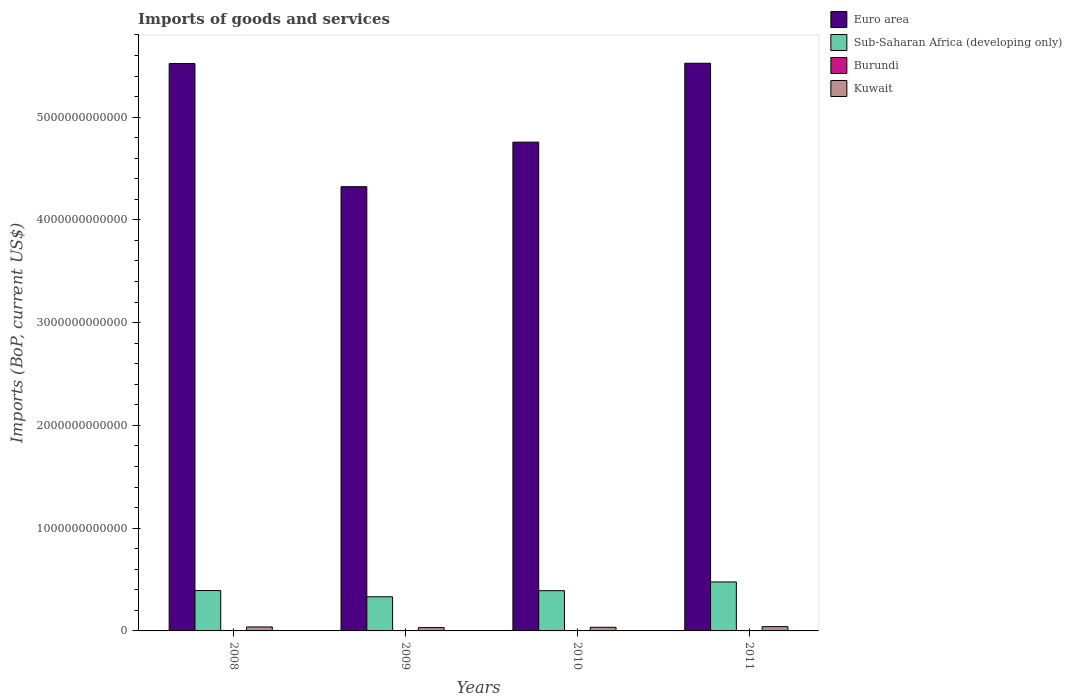How many different coloured bars are there?
Your answer should be compact. 4. How many bars are there on the 1st tick from the right?
Give a very brief answer. 4. What is the amount spent on imports in Kuwait in 2009?
Your answer should be compact. 3.23e+1. Across all years, what is the maximum amount spent on imports in Sub-Saharan Africa (developing only)?
Your answer should be very brief. 4.76e+11. Across all years, what is the minimum amount spent on imports in Euro area?
Offer a very short reply. 4.32e+12. What is the total amount spent on imports in Burundi in the graph?
Offer a terse response. 2.49e+09. What is the difference between the amount spent on imports in Kuwait in 2008 and that in 2010?
Provide a succinct answer. 3.36e+09. What is the difference between the amount spent on imports in Euro area in 2011 and the amount spent on imports in Kuwait in 2009?
Give a very brief answer. 5.49e+12. What is the average amount spent on imports in Burundi per year?
Keep it short and to the point. 6.21e+08. In the year 2010, what is the difference between the amount spent on imports in Burundi and amount spent on imports in Sub-Saharan Africa (developing only)?
Your response must be concise. -3.91e+11. In how many years, is the amount spent on imports in Kuwait greater than 4400000000000 US$?
Offer a terse response. 0. What is the ratio of the amount spent on imports in Kuwait in 2010 to that in 2011?
Provide a succinct answer. 0.85. Is the amount spent on imports in Burundi in 2009 less than that in 2010?
Keep it short and to the point. Yes. What is the difference between the highest and the second highest amount spent on imports in Euro area?
Provide a short and direct response. 3.06e+09. What is the difference between the highest and the lowest amount spent on imports in Kuwait?
Provide a short and direct response. 9.34e+09. Is the sum of the amount spent on imports in Sub-Saharan Africa (developing only) in 2010 and 2011 greater than the maximum amount spent on imports in Burundi across all years?
Offer a terse response. Yes. What does the 2nd bar from the right in 2009 represents?
Give a very brief answer. Burundi. What is the difference between two consecutive major ticks on the Y-axis?
Your response must be concise. 1.00e+12. How many legend labels are there?
Offer a terse response. 4. What is the title of the graph?
Provide a short and direct response. Imports of goods and services. What is the label or title of the Y-axis?
Make the answer very short. Imports (BoP, current US$). What is the Imports (BoP, current US$) of Euro area in 2008?
Keep it short and to the point. 5.52e+12. What is the Imports (BoP, current US$) in Sub-Saharan Africa (developing only) in 2008?
Give a very brief answer. 3.93e+11. What is the Imports (BoP, current US$) in Burundi in 2008?
Your answer should be compact. 5.94e+08. What is the Imports (BoP, current US$) in Kuwait in 2008?
Offer a very short reply. 3.87e+1. What is the Imports (BoP, current US$) in Euro area in 2009?
Make the answer very short. 4.32e+12. What is the Imports (BoP, current US$) in Sub-Saharan Africa (developing only) in 2009?
Give a very brief answer. 3.32e+11. What is the Imports (BoP, current US$) of Burundi in 2009?
Provide a short and direct response. 5.20e+08. What is the Imports (BoP, current US$) in Kuwait in 2009?
Give a very brief answer. 3.23e+1. What is the Imports (BoP, current US$) of Euro area in 2010?
Your answer should be very brief. 4.76e+12. What is the Imports (BoP, current US$) of Sub-Saharan Africa (developing only) in 2010?
Ensure brevity in your answer.  3.92e+11. What is the Imports (BoP, current US$) in Burundi in 2010?
Ensure brevity in your answer.  6.07e+08. What is the Imports (BoP, current US$) of Kuwait in 2010?
Provide a succinct answer. 3.54e+1. What is the Imports (BoP, current US$) in Euro area in 2011?
Your answer should be compact. 5.52e+12. What is the Imports (BoP, current US$) in Sub-Saharan Africa (developing only) in 2011?
Make the answer very short. 4.76e+11. What is the Imports (BoP, current US$) in Burundi in 2011?
Offer a terse response. 7.65e+08. What is the Imports (BoP, current US$) of Kuwait in 2011?
Provide a succinct answer. 4.16e+1. Across all years, what is the maximum Imports (BoP, current US$) of Euro area?
Keep it short and to the point. 5.52e+12. Across all years, what is the maximum Imports (BoP, current US$) in Sub-Saharan Africa (developing only)?
Give a very brief answer. 4.76e+11. Across all years, what is the maximum Imports (BoP, current US$) of Burundi?
Your response must be concise. 7.65e+08. Across all years, what is the maximum Imports (BoP, current US$) in Kuwait?
Offer a very short reply. 4.16e+1. Across all years, what is the minimum Imports (BoP, current US$) in Euro area?
Your response must be concise. 4.32e+12. Across all years, what is the minimum Imports (BoP, current US$) in Sub-Saharan Africa (developing only)?
Provide a succinct answer. 3.32e+11. Across all years, what is the minimum Imports (BoP, current US$) of Burundi?
Provide a succinct answer. 5.20e+08. Across all years, what is the minimum Imports (BoP, current US$) in Kuwait?
Your answer should be very brief. 3.23e+1. What is the total Imports (BoP, current US$) of Euro area in the graph?
Your response must be concise. 2.01e+13. What is the total Imports (BoP, current US$) in Sub-Saharan Africa (developing only) in the graph?
Make the answer very short. 1.59e+12. What is the total Imports (BoP, current US$) in Burundi in the graph?
Provide a short and direct response. 2.49e+09. What is the total Imports (BoP, current US$) of Kuwait in the graph?
Your answer should be very brief. 1.48e+11. What is the difference between the Imports (BoP, current US$) of Euro area in 2008 and that in 2009?
Make the answer very short. 1.20e+12. What is the difference between the Imports (BoP, current US$) in Sub-Saharan Africa (developing only) in 2008 and that in 2009?
Offer a very short reply. 6.07e+1. What is the difference between the Imports (BoP, current US$) of Burundi in 2008 and that in 2009?
Provide a short and direct response. 7.46e+07. What is the difference between the Imports (BoP, current US$) in Kuwait in 2008 and that in 2009?
Provide a short and direct response. 6.45e+09. What is the difference between the Imports (BoP, current US$) of Euro area in 2008 and that in 2010?
Offer a very short reply. 7.65e+11. What is the difference between the Imports (BoP, current US$) of Sub-Saharan Africa (developing only) in 2008 and that in 2010?
Give a very brief answer. 1.30e+09. What is the difference between the Imports (BoP, current US$) of Burundi in 2008 and that in 2010?
Give a very brief answer. -1.25e+07. What is the difference between the Imports (BoP, current US$) in Kuwait in 2008 and that in 2010?
Your response must be concise. 3.36e+09. What is the difference between the Imports (BoP, current US$) in Euro area in 2008 and that in 2011?
Ensure brevity in your answer.  -3.06e+09. What is the difference between the Imports (BoP, current US$) in Sub-Saharan Africa (developing only) in 2008 and that in 2011?
Offer a terse response. -8.35e+1. What is the difference between the Imports (BoP, current US$) in Burundi in 2008 and that in 2011?
Provide a short and direct response. -1.71e+08. What is the difference between the Imports (BoP, current US$) of Kuwait in 2008 and that in 2011?
Provide a short and direct response. -2.89e+09. What is the difference between the Imports (BoP, current US$) in Euro area in 2009 and that in 2010?
Offer a very short reply. -4.34e+11. What is the difference between the Imports (BoP, current US$) of Sub-Saharan Africa (developing only) in 2009 and that in 2010?
Your response must be concise. -5.94e+1. What is the difference between the Imports (BoP, current US$) of Burundi in 2009 and that in 2010?
Provide a short and direct response. -8.71e+07. What is the difference between the Imports (BoP, current US$) of Kuwait in 2009 and that in 2010?
Provide a short and direct response. -3.08e+09. What is the difference between the Imports (BoP, current US$) of Euro area in 2009 and that in 2011?
Your response must be concise. -1.20e+12. What is the difference between the Imports (BoP, current US$) in Sub-Saharan Africa (developing only) in 2009 and that in 2011?
Ensure brevity in your answer.  -1.44e+11. What is the difference between the Imports (BoP, current US$) of Burundi in 2009 and that in 2011?
Give a very brief answer. -2.46e+08. What is the difference between the Imports (BoP, current US$) of Kuwait in 2009 and that in 2011?
Keep it short and to the point. -9.34e+09. What is the difference between the Imports (BoP, current US$) in Euro area in 2010 and that in 2011?
Give a very brief answer. -7.68e+11. What is the difference between the Imports (BoP, current US$) in Sub-Saharan Africa (developing only) in 2010 and that in 2011?
Ensure brevity in your answer.  -8.48e+1. What is the difference between the Imports (BoP, current US$) of Burundi in 2010 and that in 2011?
Provide a short and direct response. -1.59e+08. What is the difference between the Imports (BoP, current US$) in Kuwait in 2010 and that in 2011?
Offer a very short reply. -6.26e+09. What is the difference between the Imports (BoP, current US$) in Euro area in 2008 and the Imports (BoP, current US$) in Sub-Saharan Africa (developing only) in 2009?
Keep it short and to the point. 5.19e+12. What is the difference between the Imports (BoP, current US$) in Euro area in 2008 and the Imports (BoP, current US$) in Burundi in 2009?
Give a very brief answer. 5.52e+12. What is the difference between the Imports (BoP, current US$) in Euro area in 2008 and the Imports (BoP, current US$) in Kuwait in 2009?
Your answer should be compact. 5.49e+12. What is the difference between the Imports (BoP, current US$) of Sub-Saharan Africa (developing only) in 2008 and the Imports (BoP, current US$) of Burundi in 2009?
Give a very brief answer. 3.92e+11. What is the difference between the Imports (BoP, current US$) in Sub-Saharan Africa (developing only) in 2008 and the Imports (BoP, current US$) in Kuwait in 2009?
Keep it short and to the point. 3.61e+11. What is the difference between the Imports (BoP, current US$) of Burundi in 2008 and the Imports (BoP, current US$) of Kuwait in 2009?
Your answer should be very brief. -3.17e+1. What is the difference between the Imports (BoP, current US$) of Euro area in 2008 and the Imports (BoP, current US$) of Sub-Saharan Africa (developing only) in 2010?
Make the answer very short. 5.13e+12. What is the difference between the Imports (BoP, current US$) in Euro area in 2008 and the Imports (BoP, current US$) in Burundi in 2010?
Provide a succinct answer. 5.52e+12. What is the difference between the Imports (BoP, current US$) in Euro area in 2008 and the Imports (BoP, current US$) in Kuwait in 2010?
Ensure brevity in your answer.  5.49e+12. What is the difference between the Imports (BoP, current US$) of Sub-Saharan Africa (developing only) in 2008 and the Imports (BoP, current US$) of Burundi in 2010?
Provide a short and direct response. 3.92e+11. What is the difference between the Imports (BoP, current US$) of Sub-Saharan Africa (developing only) in 2008 and the Imports (BoP, current US$) of Kuwait in 2010?
Keep it short and to the point. 3.58e+11. What is the difference between the Imports (BoP, current US$) of Burundi in 2008 and the Imports (BoP, current US$) of Kuwait in 2010?
Provide a short and direct response. -3.48e+1. What is the difference between the Imports (BoP, current US$) in Euro area in 2008 and the Imports (BoP, current US$) in Sub-Saharan Africa (developing only) in 2011?
Your answer should be very brief. 5.04e+12. What is the difference between the Imports (BoP, current US$) of Euro area in 2008 and the Imports (BoP, current US$) of Burundi in 2011?
Your answer should be very brief. 5.52e+12. What is the difference between the Imports (BoP, current US$) of Euro area in 2008 and the Imports (BoP, current US$) of Kuwait in 2011?
Make the answer very short. 5.48e+12. What is the difference between the Imports (BoP, current US$) in Sub-Saharan Africa (developing only) in 2008 and the Imports (BoP, current US$) in Burundi in 2011?
Your answer should be very brief. 3.92e+11. What is the difference between the Imports (BoP, current US$) in Sub-Saharan Africa (developing only) in 2008 and the Imports (BoP, current US$) in Kuwait in 2011?
Your answer should be compact. 3.51e+11. What is the difference between the Imports (BoP, current US$) in Burundi in 2008 and the Imports (BoP, current US$) in Kuwait in 2011?
Offer a very short reply. -4.10e+1. What is the difference between the Imports (BoP, current US$) of Euro area in 2009 and the Imports (BoP, current US$) of Sub-Saharan Africa (developing only) in 2010?
Offer a terse response. 3.93e+12. What is the difference between the Imports (BoP, current US$) of Euro area in 2009 and the Imports (BoP, current US$) of Burundi in 2010?
Provide a succinct answer. 4.32e+12. What is the difference between the Imports (BoP, current US$) in Euro area in 2009 and the Imports (BoP, current US$) in Kuwait in 2010?
Your response must be concise. 4.29e+12. What is the difference between the Imports (BoP, current US$) in Sub-Saharan Africa (developing only) in 2009 and the Imports (BoP, current US$) in Burundi in 2010?
Provide a short and direct response. 3.32e+11. What is the difference between the Imports (BoP, current US$) of Sub-Saharan Africa (developing only) in 2009 and the Imports (BoP, current US$) of Kuwait in 2010?
Your response must be concise. 2.97e+11. What is the difference between the Imports (BoP, current US$) of Burundi in 2009 and the Imports (BoP, current US$) of Kuwait in 2010?
Provide a succinct answer. -3.48e+1. What is the difference between the Imports (BoP, current US$) of Euro area in 2009 and the Imports (BoP, current US$) of Sub-Saharan Africa (developing only) in 2011?
Provide a succinct answer. 3.85e+12. What is the difference between the Imports (BoP, current US$) of Euro area in 2009 and the Imports (BoP, current US$) of Burundi in 2011?
Keep it short and to the point. 4.32e+12. What is the difference between the Imports (BoP, current US$) of Euro area in 2009 and the Imports (BoP, current US$) of Kuwait in 2011?
Ensure brevity in your answer.  4.28e+12. What is the difference between the Imports (BoP, current US$) of Sub-Saharan Africa (developing only) in 2009 and the Imports (BoP, current US$) of Burundi in 2011?
Provide a short and direct response. 3.31e+11. What is the difference between the Imports (BoP, current US$) of Sub-Saharan Africa (developing only) in 2009 and the Imports (BoP, current US$) of Kuwait in 2011?
Make the answer very short. 2.91e+11. What is the difference between the Imports (BoP, current US$) in Burundi in 2009 and the Imports (BoP, current US$) in Kuwait in 2011?
Ensure brevity in your answer.  -4.11e+1. What is the difference between the Imports (BoP, current US$) in Euro area in 2010 and the Imports (BoP, current US$) in Sub-Saharan Africa (developing only) in 2011?
Your response must be concise. 4.28e+12. What is the difference between the Imports (BoP, current US$) of Euro area in 2010 and the Imports (BoP, current US$) of Burundi in 2011?
Make the answer very short. 4.76e+12. What is the difference between the Imports (BoP, current US$) of Euro area in 2010 and the Imports (BoP, current US$) of Kuwait in 2011?
Your answer should be very brief. 4.71e+12. What is the difference between the Imports (BoP, current US$) of Sub-Saharan Africa (developing only) in 2010 and the Imports (BoP, current US$) of Burundi in 2011?
Your response must be concise. 3.91e+11. What is the difference between the Imports (BoP, current US$) of Sub-Saharan Africa (developing only) in 2010 and the Imports (BoP, current US$) of Kuwait in 2011?
Your answer should be compact. 3.50e+11. What is the difference between the Imports (BoP, current US$) in Burundi in 2010 and the Imports (BoP, current US$) in Kuwait in 2011?
Keep it short and to the point. -4.10e+1. What is the average Imports (BoP, current US$) of Euro area per year?
Make the answer very short. 5.03e+12. What is the average Imports (BoP, current US$) in Sub-Saharan Africa (developing only) per year?
Your answer should be compact. 3.98e+11. What is the average Imports (BoP, current US$) in Burundi per year?
Offer a very short reply. 6.21e+08. What is the average Imports (BoP, current US$) of Kuwait per year?
Provide a succinct answer. 3.70e+1. In the year 2008, what is the difference between the Imports (BoP, current US$) in Euro area and Imports (BoP, current US$) in Sub-Saharan Africa (developing only)?
Your answer should be compact. 5.13e+12. In the year 2008, what is the difference between the Imports (BoP, current US$) of Euro area and Imports (BoP, current US$) of Burundi?
Keep it short and to the point. 5.52e+12. In the year 2008, what is the difference between the Imports (BoP, current US$) in Euro area and Imports (BoP, current US$) in Kuwait?
Keep it short and to the point. 5.48e+12. In the year 2008, what is the difference between the Imports (BoP, current US$) in Sub-Saharan Africa (developing only) and Imports (BoP, current US$) in Burundi?
Keep it short and to the point. 3.92e+11. In the year 2008, what is the difference between the Imports (BoP, current US$) of Sub-Saharan Africa (developing only) and Imports (BoP, current US$) of Kuwait?
Ensure brevity in your answer.  3.54e+11. In the year 2008, what is the difference between the Imports (BoP, current US$) in Burundi and Imports (BoP, current US$) in Kuwait?
Keep it short and to the point. -3.81e+1. In the year 2009, what is the difference between the Imports (BoP, current US$) of Euro area and Imports (BoP, current US$) of Sub-Saharan Africa (developing only)?
Make the answer very short. 3.99e+12. In the year 2009, what is the difference between the Imports (BoP, current US$) of Euro area and Imports (BoP, current US$) of Burundi?
Your answer should be very brief. 4.32e+12. In the year 2009, what is the difference between the Imports (BoP, current US$) of Euro area and Imports (BoP, current US$) of Kuwait?
Give a very brief answer. 4.29e+12. In the year 2009, what is the difference between the Imports (BoP, current US$) of Sub-Saharan Africa (developing only) and Imports (BoP, current US$) of Burundi?
Your response must be concise. 3.32e+11. In the year 2009, what is the difference between the Imports (BoP, current US$) of Sub-Saharan Africa (developing only) and Imports (BoP, current US$) of Kuwait?
Provide a succinct answer. 3.00e+11. In the year 2009, what is the difference between the Imports (BoP, current US$) in Burundi and Imports (BoP, current US$) in Kuwait?
Ensure brevity in your answer.  -3.18e+1. In the year 2010, what is the difference between the Imports (BoP, current US$) in Euro area and Imports (BoP, current US$) in Sub-Saharan Africa (developing only)?
Ensure brevity in your answer.  4.36e+12. In the year 2010, what is the difference between the Imports (BoP, current US$) in Euro area and Imports (BoP, current US$) in Burundi?
Provide a succinct answer. 4.76e+12. In the year 2010, what is the difference between the Imports (BoP, current US$) of Euro area and Imports (BoP, current US$) of Kuwait?
Keep it short and to the point. 4.72e+12. In the year 2010, what is the difference between the Imports (BoP, current US$) in Sub-Saharan Africa (developing only) and Imports (BoP, current US$) in Burundi?
Your response must be concise. 3.91e+11. In the year 2010, what is the difference between the Imports (BoP, current US$) of Sub-Saharan Africa (developing only) and Imports (BoP, current US$) of Kuwait?
Ensure brevity in your answer.  3.56e+11. In the year 2010, what is the difference between the Imports (BoP, current US$) in Burundi and Imports (BoP, current US$) in Kuwait?
Give a very brief answer. -3.47e+1. In the year 2011, what is the difference between the Imports (BoP, current US$) in Euro area and Imports (BoP, current US$) in Sub-Saharan Africa (developing only)?
Your response must be concise. 5.05e+12. In the year 2011, what is the difference between the Imports (BoP, current US$) in Euro area and Imports (BoP, current US$) in Burundi?
Make the answer very short. 5.52e+12. In the year 2011, what is the difference between the Imports (BoP, current US$) of Euro area and Imports (BoP, current US$) of Kuwait?
Ensure brevity in your answer.  5.48e+12. In the year 2011, what is the difference between the Imports (BoP, current US$) in Sub-Saharan Africa (developing only) and Imports (BoP, current US$) in Burundi?
Provide a short and direct response. 4.76e+11. In the year 2011, what is the difference between the Imports (BoP, current US$) of Sub-Saharan Africa (developing only) and Imports (BoP, current US$) of Kuwait?
Your answer should be compact. 4.35e+11. In the year 2011, what is the difference between the Imports (BoP, current US$) in Burundi and Imports (BoP, current US$) in Kuwait?
Your answer should be very brief. -4.08e+1. What is the ratio of the Imports (BoP, current US$) in Euro area in 2008 to that in 2009?
Make the answer very short. 1.28. What is the ratio of the Imports (BoP, current US$) in Sub-Saharan Africa (developing only) in 2008 to that in 2009?
Offer a terse response. 1.18. What is the ratio of the Imports (BoP, current US$) of Burundi in 2008 to that in 2009?
Your response must be concise. 1.14. What is the ratio of the Imports (BoP, current US$) in Kuwait in 2008 to that in 2009?
Your answer should be very brief. 1.2. What is the ratio of the Imports (BoP, current US$) in Euro area in 2008 to that in 2010?
Your answer should be very brief. 1.16. What is the ratio of the Imports (BoP, current US$) in Sub-Saharan Africa (developing only) in 2008 to that in 2010?
Your answer should be compact. 1. What is the ratio of the Imports (BoP, current US$) of Burundi in 2008 to that in 2010?
Your answer should be very brief. 0.98. What is the ratio of the Imports (BoP, current US$) of Kuwait in 2008 to that in 2010?
Keep it short and to the point. 1.1. What is the ratio of the Imports (BoP, current US$) of Euro area in 2008 to that in 2011?
Keep it short and to the point. 1. What is the ratio of the Imports (BoP, current US$) of Sub-Saharan Africa (developing only) in 2008 to that in 2011?
Your answer should be very brief. 0.82. What is the ratio of the Imports (BoP, current US$) in Burundi in 2008 to that in 2011?
Your answer should be very brief. 0.78. What is the ratio of the Imports (BoP, current US$) in Kuwait in 2008 to that in 2011?
Ensure brevity in your answer.  0.93. What is the ratio of the Imports (BoP, current US$) of Euro area in 2009 to that in 2010?
Your answer should be very brief. 0.91. What is the ratio of the Imports (BoP, current US$) in Sub-Saharan Africa (developing only) in 2009 to that in 2010?
Provide a succinct answer. 0.85. What is the ratio of the Imports (BoP, current US$) in Burundi in 2009 to that in 2010?
Your answer should be compact. 0.86. What is the ratio of the Imports (BoP, current US$) in Kuwait in 2009 to that in 2010?
Ensure brevity in your answer.  0.91. What is the ratio of the Imports (BoP, current US$) of Euro area in 2009 to that in 2011?
Keep it short and to the point. 0.78. What is the ratio of the Imports (BoP, current US$) in Sub-Saharan Africa (developing only) in 2009 to that in 2011?
Your answer should be compact. 0.7. What is the ratio of the Imports (BoP, current US$) of Burundi in 2009 to that in 2011?
Offer a terse response. 0.68. What is the ratio of the Imports (BoP, current US$) in Kuwait in 2009 to that in 2011?
Your response must be concise. 0.78. What is the ratio of the Imports (BoP, current US$) in Euro area in 2010 to that in 2011?
Make the answer very short. 0.86. What is the ratio of the Imports (BoP, current US$) in Sub-Saharan Africa (developing only) in 2010 to that in 2011?
Provide a short and direct response. 0.82. What is the ratio of the Imports (BoP, current US$) in Burundi in 2010 to that in 2011?
Provide a short and direct response. 0.79. What is the ratio of the Imports (BoP, current US$) of Kuwait in 2010 to that in 2011?
Keep it short and to the point. 0.85. What is the difference between the highest and the second highest Imports (BoP, current US$) of Euro area?
Offer a very short reply. 3.06e+09. What is the difference between the highest and the second highest Imports (BoP, current US$) in Sub-Saharan Africa (developing only)?
Offer a very short reply. 8.35e+1. What is the difference between the highest and the second highest Imports (BoP, current US$) in Burundi?
Your response must be concise. 1.59e+08. What is the difference between the highest and the second highest Imports (BoP, current US$) in Kuwait?
Make the answer very short. 2.89e+09. What is the difference between the highest and the lowest Imports (BoP, current US$) in Euro area?
Offer a terse response. 1.20e+12. What is the difference between the highest and the lowest Imports (BoP, current US$) in Sub-Saharan Africa (developing only)?
Offer a very short reply. 1.44e+11. What is the difference between the highest and the lowest Imports (BoP, current US$) in Burundi?
Offer a terse response. 2.46e+08. What is the difference between the highest and the lowest Imports (BoP, current US$) of Kuwait?
Keep it short and to the point. 9.34e+09. 